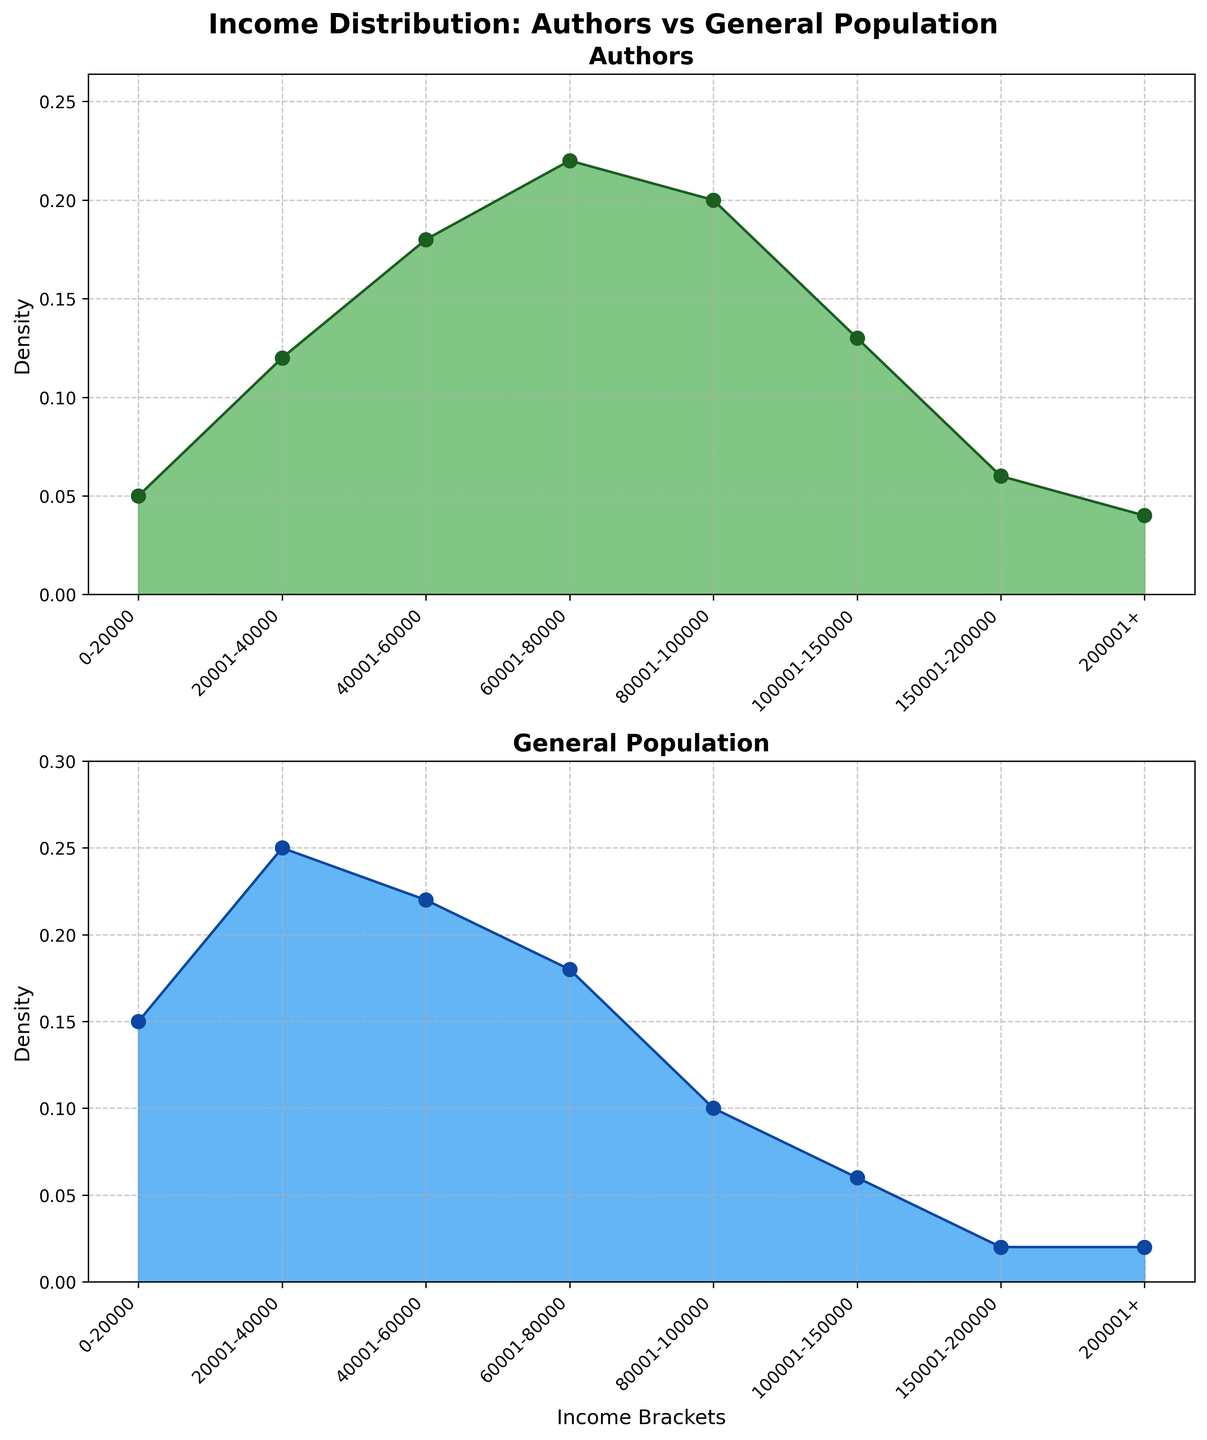What is the title of the figure? Look at the top center of the figure to find the title in bold font that describes what the figure is about.
Answer: Income Distribution: Authors vs General Population Which income bracket has the highest density for authors? Observe the subplot labeled 'Authors' and identify the income bracket with the tallest filled area.
Answer: 60001-80000 What is the approximate density for the general population in the 40001-60000 income bracket? Refer to the subplot labeled 'General Population' and observe the height of the filled area for the 40001-60000 bracket.
Answer: 0.22 Compare the densities for authors and the general population in the 20001-40000 income bracket. Look at both subplots and compare the heights of the filled areas for the 20001-40000 income bracket.
Answer: Authors: 0.12, General Population: 0.25 In which income bracket do authors have a higher density compared to the general population? Identify the income brackets where the filled area in the 'Authors' subplot is taller than in the 'General Population' subplot.
Answer: 0-20000 and 20001-40000 Which subplot shows a higher density peak, and in which income bracket does it occur? Compare the highest peaks in both the 'Authors' and 'General Population' subplots, identifying the income brackets where these peaks occur.
Answer: Authors in 60001-80000 What can you infer about the income distribution of authors compared to the general population? Observe how the densities differ across income brackets in both subplots and summarize the overall trend.
Answer: Authors tend to have higher densities in higher income brackets How do the densities of authors and the general population compare in the >200001 income bracket? Compare the height of the filled areas for the >200001 income bracket in both subplots.
Answer: Authors: 0.04, General Population: 0.02 Which group has a higher density in the 200001-40000 income bracket, and by how much? Compare the densities in the 20001-40000 income bracket for both subplots and calculate the difference.
Answer: General Population by 0.13 